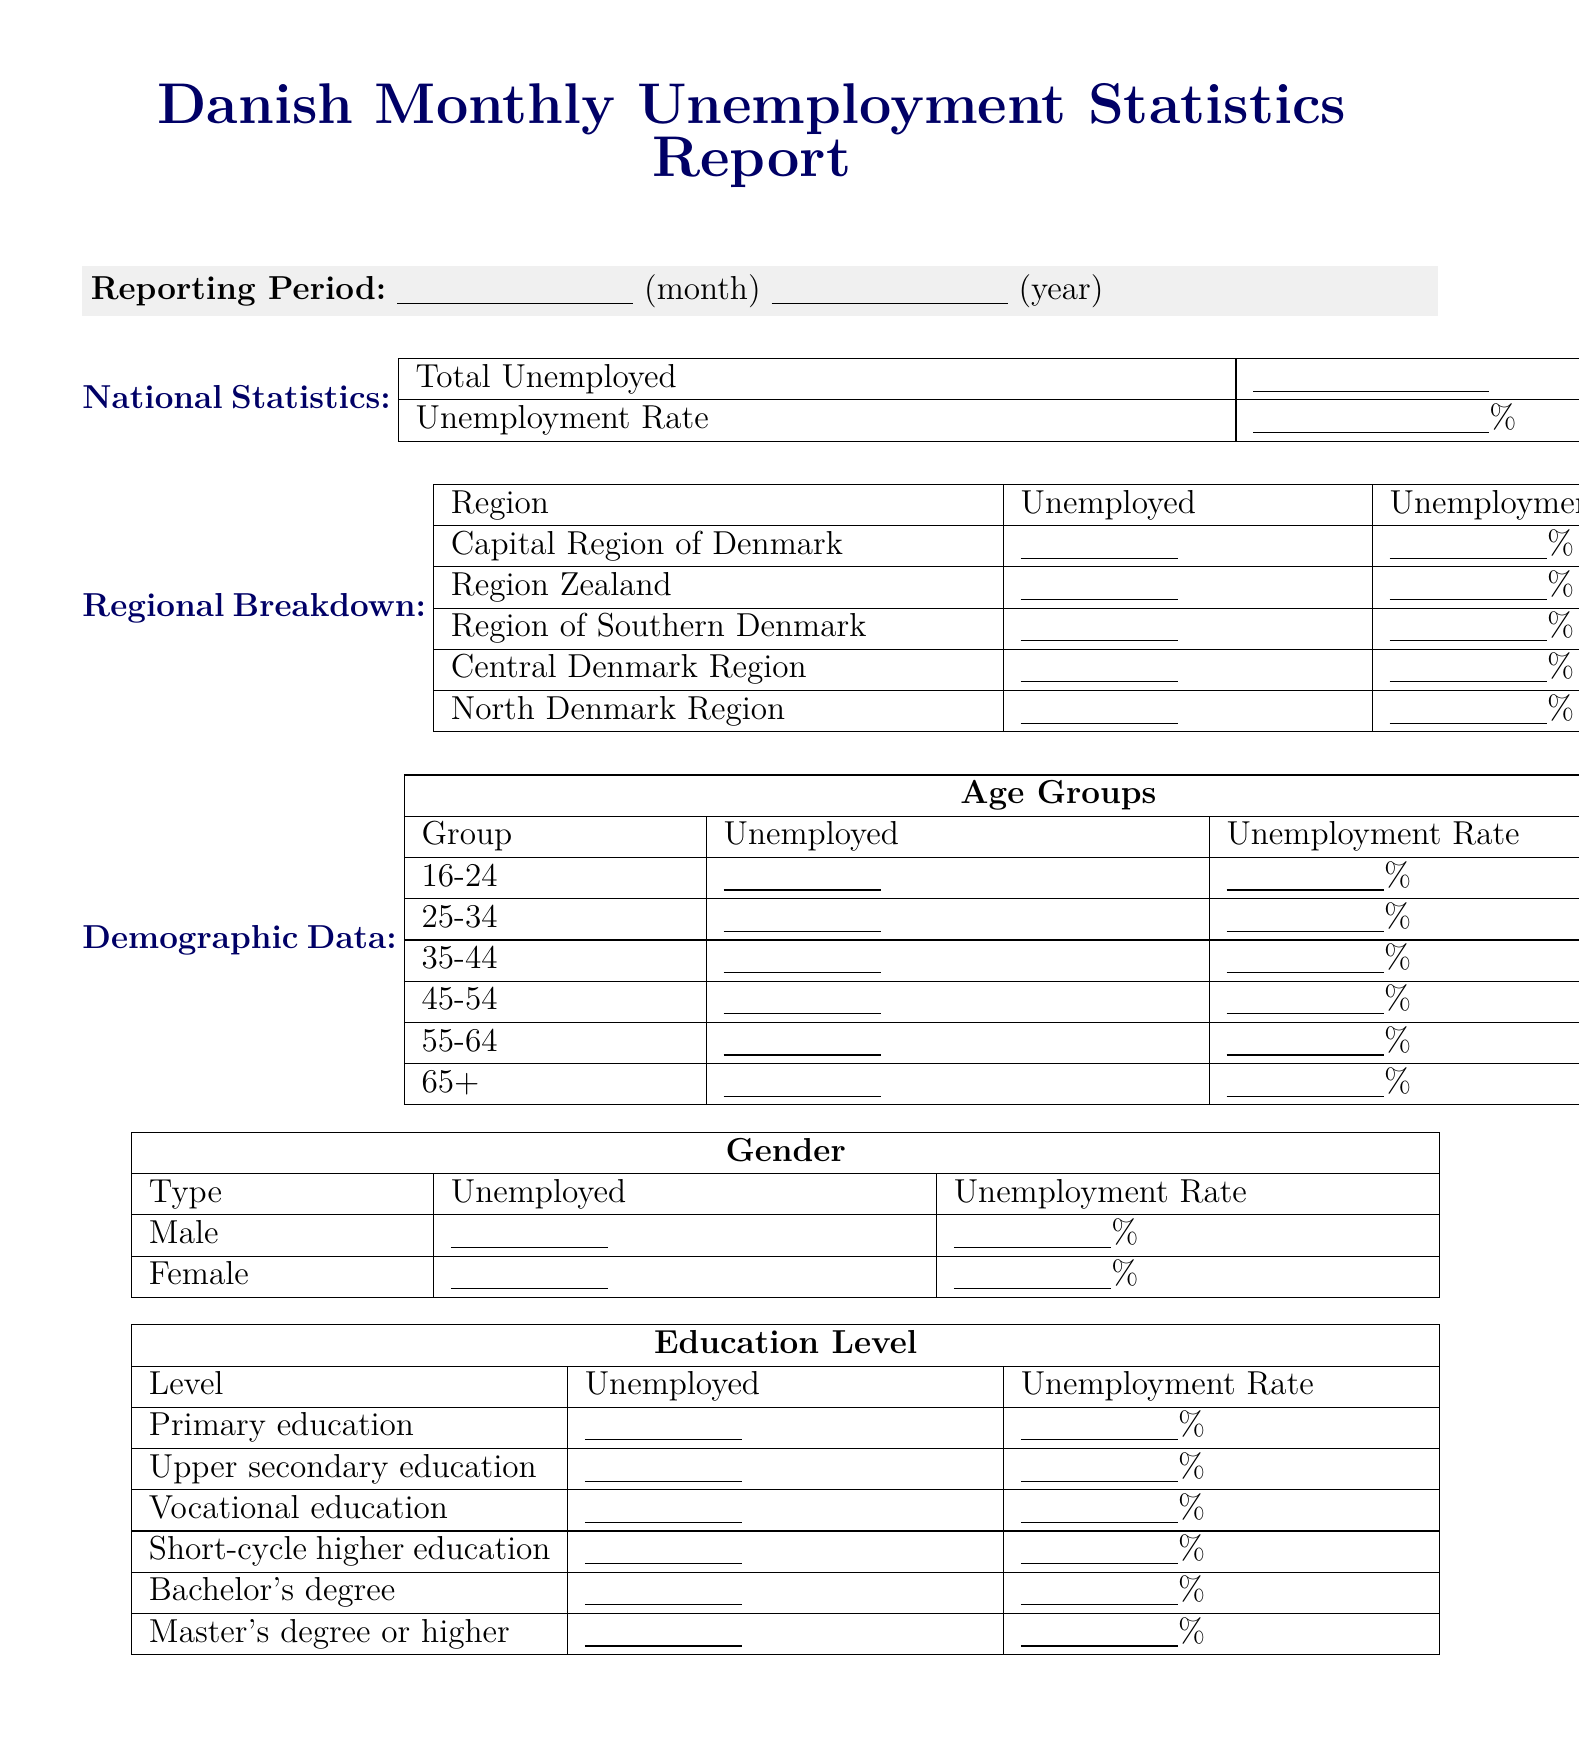what is the title of the report? The title of the report is specified at the beginning of the document.
Answer: Danish Monthly Unemployment Statistics Report which region has the highest unemployment rate? This would require comparing unemployment rates from the regional breakdown.
Answer: Enter percentage what is the total number of unemployed individuals? The total unemployed number is presented in the national statistics section.
Answer: Enter total number how many unemployed individuals are aged 25-34? This information is found in the demographic data under age groups.
Answer: Enter number what is the seasonally adjusted unemployment rate? The seasonally adjusted unemployment rate is a specific statistic mentioned in the document.
Answer: Enter percentage who prepared this report? The preparer of the report is noted before the approval section.
Answer: Enter name how many job vacancies are reported? The total number of job vacancies can be found in the additional statistics section.
Answer: Enter number what percentage of the total unemployed are long-term unemployed? This percentage is provided in the long-term unemployment section of the document.
Answer: Enter percentage what is the youth unemployment rate? The youth unemployment rate is specified as one of the additional statistics in the document.
Answer: Enter percentage 